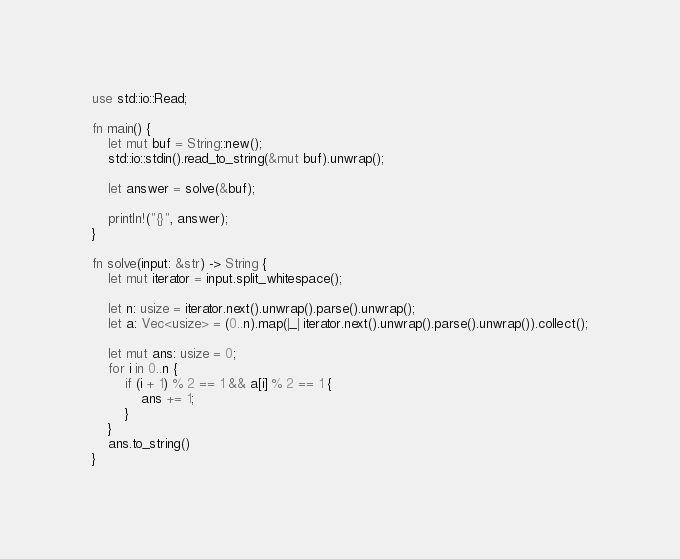<code> <loc_0><loc_0><loc_500><loc_500><_Rust_>use std::io::Read;

fn main() {
    let mut buf = String::new();
    std::io::stdin().read_to_string(&mut buf).unwrap();

    let answer = solve(&buf);

    println!("{}", answer);
}

fn solve(input: &str) -> String {
    let mut iterator = input.split_whitespace();

    let n: usize = iterator.next().unwrap().parse().unwrap();
    let a: Vec<usize> = (0..n).map(|_| iterator.next().unwrap().parse().unwrap()).collect();

    let mut ans: usize = 0;
    for i in 0..n {
        if (i + 1) % 2 == 1 && a[i] % 2 == 1 {
            ans += 1;
        }
    }
    ans.to_string()
}
</code> 